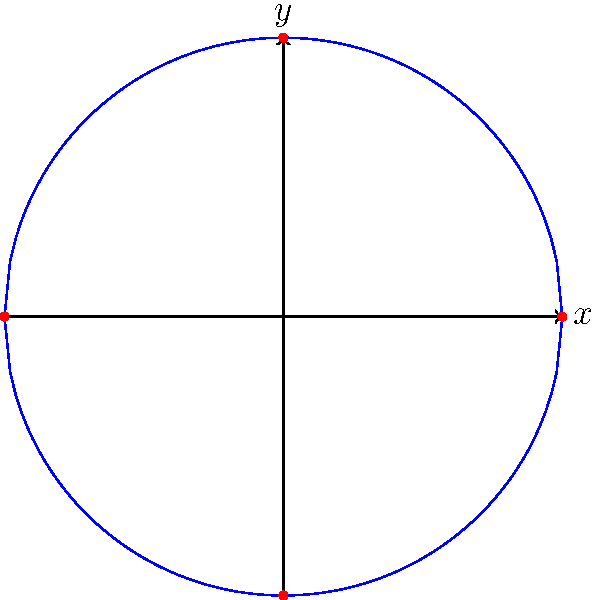As part of a project to create a symmetrical educational symbol, you need to transform the coordinates of a circle centered at the origin with radius 1. The goal is to stretch the circle vertically by a factor of 2 while maintaining its horizontal dimensions. What will be the coordinates of the point $(0,1)$ after this transformation? Let's approach this step-by-step:

1) The original circle is described by the equation $x^2 + y^2 = 1$.

2) The point $(0,1)$ lies on this circle at the top.

3) To stretch the circle vertically by a factor of 2, we need to transform the y-coordinate while leaving the x-coordinate unchanged.

4) The transformation can be represented as:
   $x' = x$
   $y' = 2y$

5) For the point $(0,1)$:
   $x' = 0$
   $y' = 2(1) = 2$

6) Therefore, after the transformation, the point $(0,1)$ will move to $(0,2)$.

This transformation will turn the circle into an ellipse, stretching it to twice its original height while maintaining its width. This kind of transformation can be useful in creating symmetrical educational symbols that emphasize vertical elements.
Answer: $(0,2)$ 